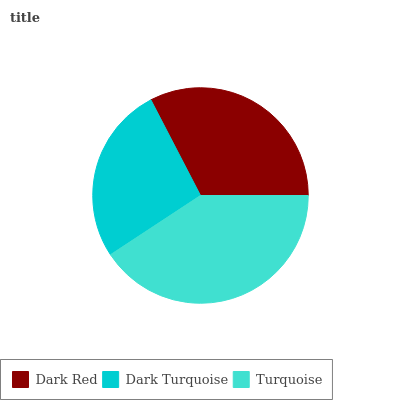Is Dark Turquoise the minimum?
Answer yes or no. Yes. Is Turquoise the maximum?
Answer yes or no. Yes. Is Turquoise the minimum?
Answer yes or no. No. Is Dark Turquoise the maximum?
Answer yes or no. No. Is Turquoise greater than Dark Turquoise?
Answer yes or no. Yes. Is Dark Turquoise less than Turquoise?
Answer yes or no. Yes. Is Dark Turquoise greater than Turquoise?
Answer yes or no. No. Is Turquoise less than Dark Turquoise?
Answer yes or no. No. Is Dark Red the high median?
Answer yes or no. Yes. Is Dark Red the low median?
Answer yes or no. Yes. Is Turquoise the high median?
Answer yes or no. No. Is Dark Turquoise the low median?
Answer yes or no. No. 